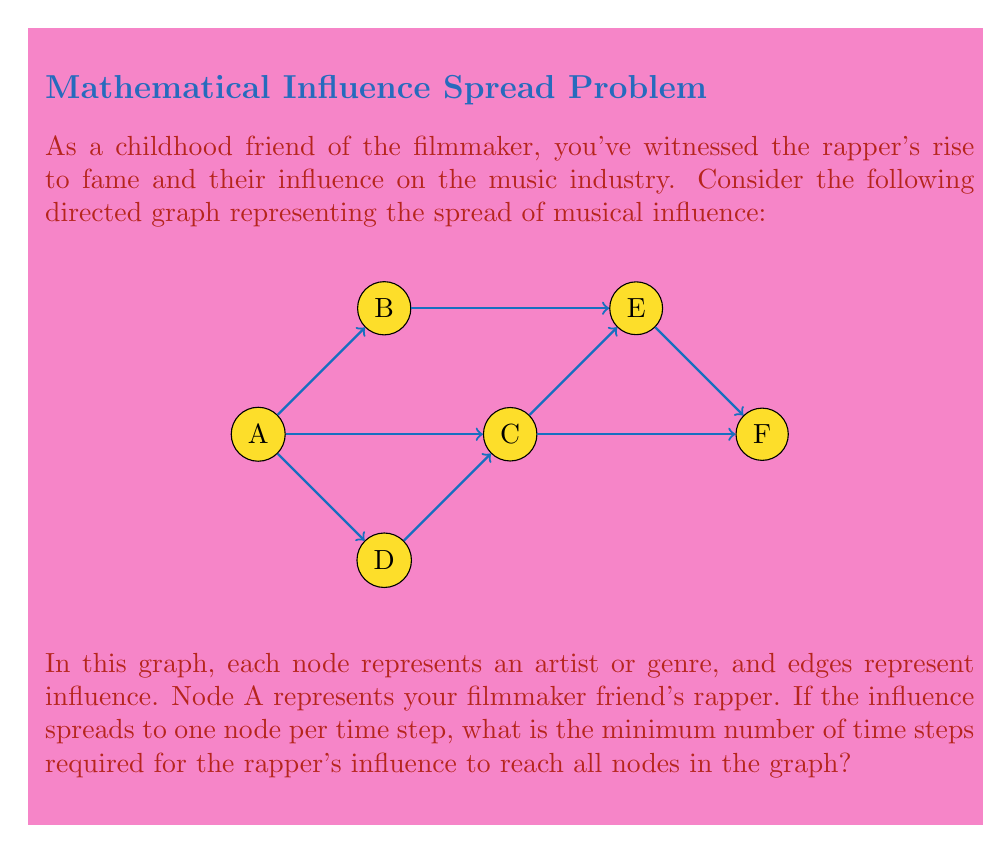Solve this math problem. To solve this problem, we need to find the longest path from node A to any other node in the graph. This is because the influence spreads one node at a time, and we want to ensure it reaches all nodes.

Let's analyze the paths from A to each node:

1. A to B: 1 step
2. A to C: 1 step
3. A to D: 1 step
4. A to E: 
   - Via B: A → B → E (2 steps)
   - Via C: A → C → E (2 steps)
5. A to F:
   - Via C: A → C → F (2 steps)
   - Via B and E: A → B → E → F (3 steps)
   - Via C and E: A → C → E → F (3 steps)

The longest path is from A to F, which takes 3 steps. This means that after 3 time steps, the rapper's influence will have reached all nodes in the graph.

To verify, let's see how the influence spreads over time:
- Time step 1: A influences B, C, and D
- Time step 2: B and C influence E, C influences F
- Time step 3: E influences F (if it hasn't been influenced already)

After these 3 time steps, all nodes have been influenced.
Answer: 3 time steps 